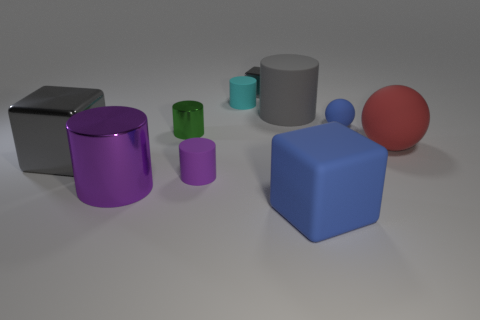There is a metallic cube that is behind the blue matte object that is on the right side of the big blue matte cube; what is its color?
Ensure brevity in your answer.  Gray. There is a large object that is behind the tiny matte ball; what material is it?
Offer a very short reply. Rubber. Is the number of tiny gray metallic objects less than the number of big cylinders?
Offer a terse response. Yes. Does the tiny cyan matte thing have the same shape as the tiny metallic object that is in front of the tiny blue ball?
Keep it short and to the point. Yes. There is a metal object that is both behind the big gray block and to the left of the cyan cylinder; what shape is it?
Keep it short and to the point. Cylinder. Are there an equal number of small green metal objects on the right side of the small gray block and purple cylinders that are behind the purple metal cylinder?
Ensure brevity in your answer.  No. Do the metal object that is left of the large metallic cylinder and the big blue rubber object have the same shape?
Provide a succinct answer. Yes. How many blue things are small metal cylinders or small spheres?
Your response must be concise. 1. There is a tiny gray thing that is the same shape as the big blue matte thing; what is it made of?
Your answer should be very brief. Metal. The purple thing that is to the right of the big shiny cylinder has what shape?
Provide a succinct answer. Cylinder. 